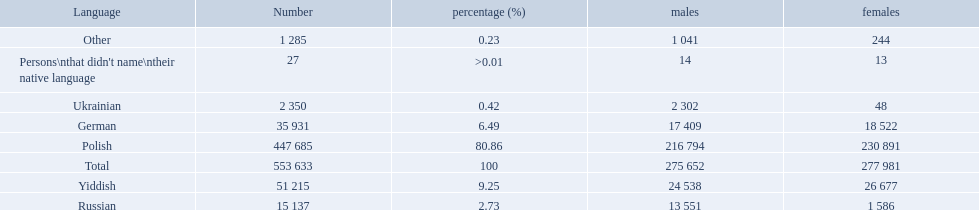What was the least spoken language Ukrainian. What was the most spoken? Polish. 